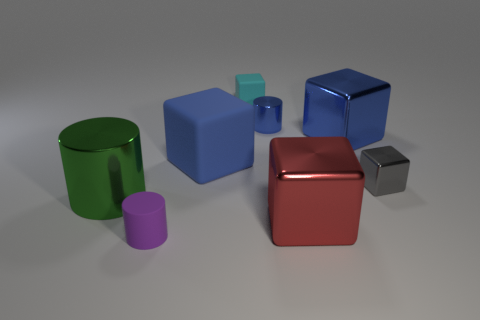Subtract all cubes. How many objects are left? 3 Subtract all small gray blocks. How many blocks are left? 4 Subtract 1 blue cylinders. How many objects are left? 7 Subtract 2 cylinders. How many cylinders are left? 1 Subtract all purple blocks. Subtract all yellow balls. How many blocks are left? 5 Subtract all gray spheres. How many brown cubes are left? 0 Subtract all large blue metallic blocks. Subtract all purple rubber cylinders. How many objects are left? 6 Add 3 cylinders. How many cylinders are left? 6 Add 1 green cylinders. How many green cylinders exist? 2 Add 1 large things. How many objects exist? 9 